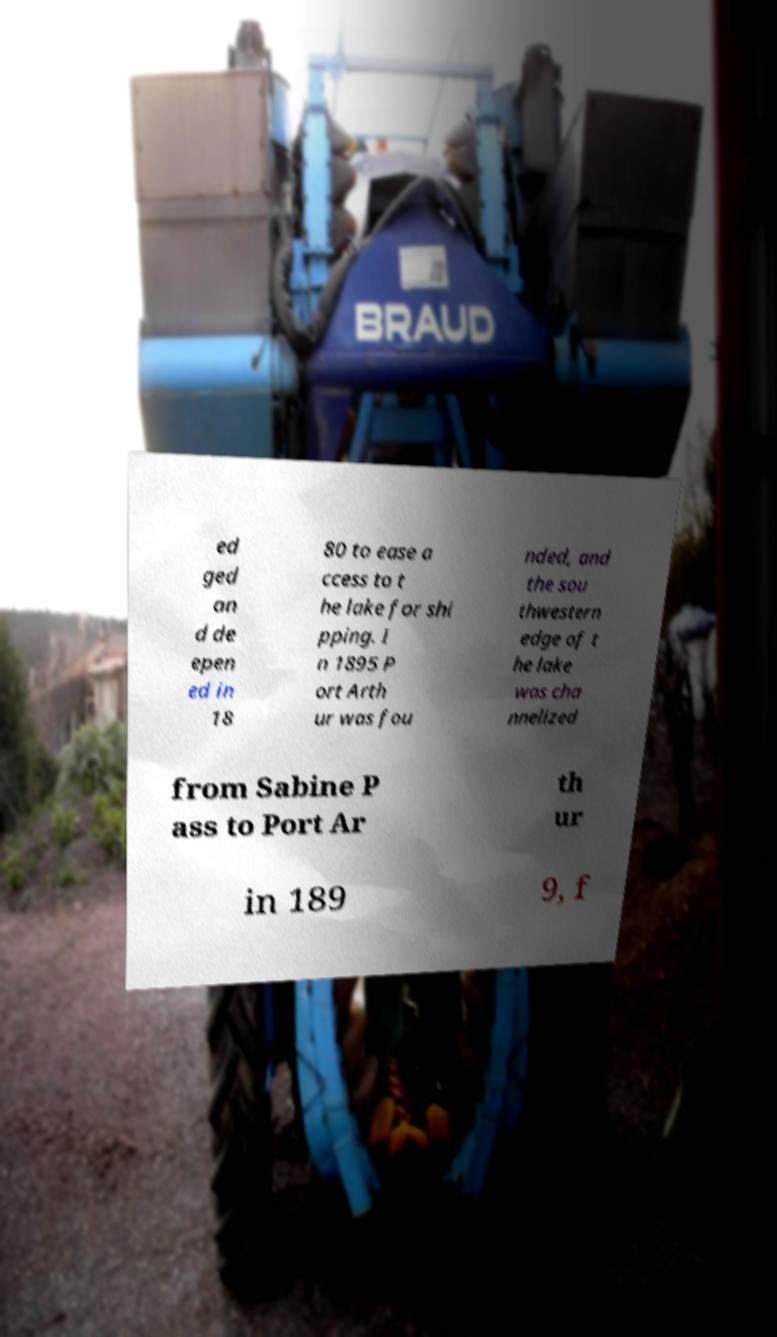Can you accurately transcribe the text from the provided image for me? ed ged an d de epen ed in 18 80 to ease a ccess to t he lake for shi pping. I n 1895 P ort Arth ur was fou nded, and the sou thwestern edge of t he lake was cha nnelized from Sabine P ass to Port Ar th ur in 189 9, f 